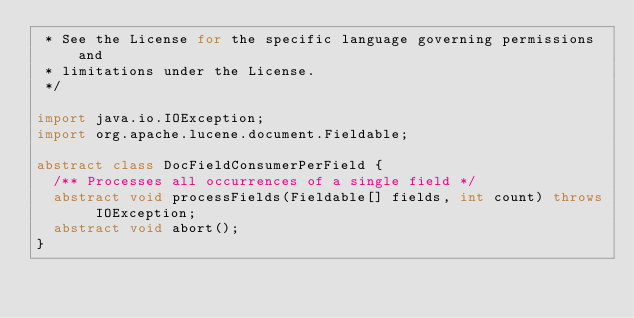<code> <loc_0><loc_0><loc_500><loc_500><_Java_> * See the License for the specific language governing permissions and
 * limitations under the License.
 */

import java.io.IOException;
import org.apache.lucene.document.Fieldable;

abstract class DocFieldConsumerPerField {
  /** Processes all occurrences of a single field */
  abstract void processFields(Fieldable[] fields, int count) throws IOException;
  abstract void abort();
}
</code> 